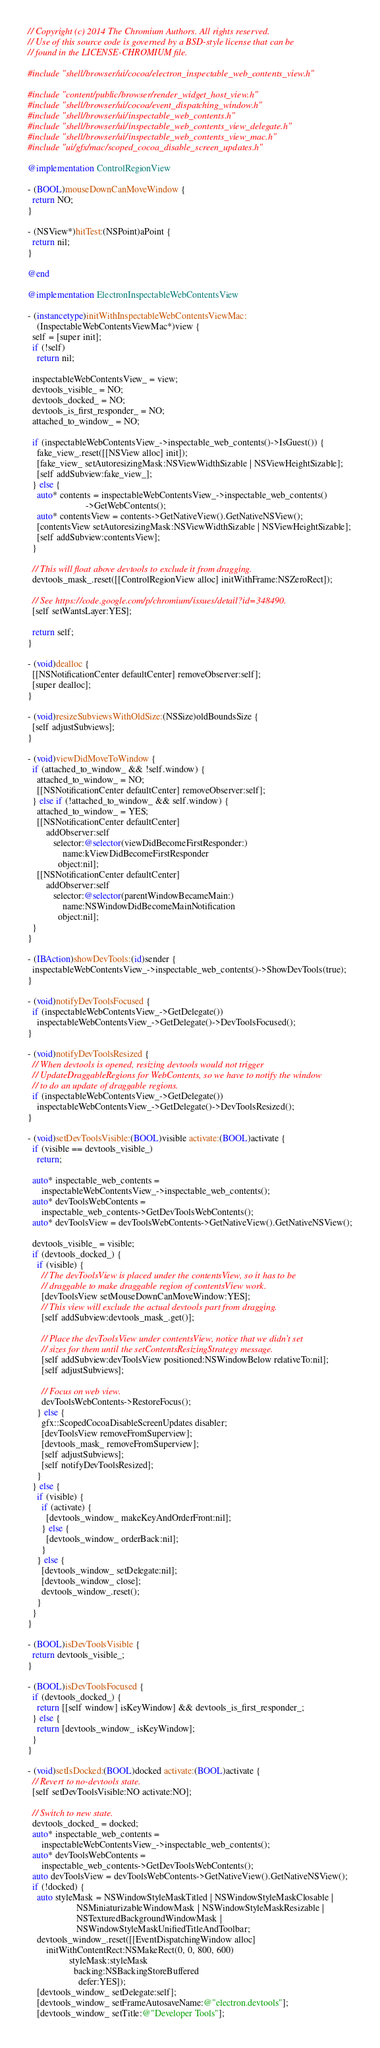<code> <loc_0><loc_0><loc_500><loc_500><_ObjectiveC_>// Copyright (c) 2014 The Chromium Authors. All rights reserved.
// Use of this source code is governed by a BSD-style license that can be
// found in the LICENSE-CHROMIUM file.

#include "shell/browser/ui/cocoa/electron_inspectable_web_contents_view.h"

#include "content/public/browser/render_widget_host_view.h"
#include "shell/browser/ui/cocoa/event_dispatching_window.h"
#include "shell/browser/ui/inspectable_web_contents.h"
#include "shell/browser/ui/inspectable_web_contents_view_delegate.h"
#include "shell/browser/ui/inspectable_web_contents_view_mac.h"
#include "ui/gfx/mac/scoped_cocoa_disable_screen_updates.h"

@implementation ControlRegionView

- (BOOL)mouseDownCanMoveWindow {
  return NO;
}

- (NSView*)hitTest:(NSPoint)aPoint {
  return nil;
}

@end

@implementation ElectronInspectableWebContentsView

- (instancetype)initWithInspectableWebContentsViewMac:
    (InspectableWebContentsViewMac*)view {
  self = [super init];
  if (!self)
    return nil;

  inspectableWebContentsView_ = view;
  devtools_visible_ = NO;
  devtools_docked_ = NO;
  devtools_is_first_responder_ = NO;
  attached_to_window_ = NO;

  if (inspectableWebContentsView_->inspectable_web_contents()->IsGuest()) {
    fake_view_.reset([[NSView alloc] init]);
    [fake_view_ setAutoresizingMask:NSViewWidthSizable | NSViewHeightSizable];
    [self addSubview:fake_view_];
  } else {
    auto* contents = inspectableWebContentsView_->inspectable_web_contents()
                         ->GetWebContents();
    auto* contentsView = contents->GetNativeView().GetNativeNSView();
    [contentsView setAutoresizingMask:NSViewWidthSizable | NSViewHeightSizable];
    [self addSubview:contentsView];
  }

  // This will float above devtools to exclude it from dragging.
  devtools_mask_.reset([[ControlRegionView alloc] initWithFrame:NSZeroRect]);

  // See https://code.google.com/p/chromium/issues/detail?id=348490.
  [self setWantsLayer:YES];

  return self;
}

- (void)dealloc {
  [[NSNotificationCenter defaultCenter] removeObserver:self];
  [super dealloc];
}

- (void)resizeSubviewsWithOldSize:(NSSize)oldBoundsSize {
  [self adjustSubviews];
}

- (void)viewDidMoveToWindow {
  if (attached_to_window_ && !self.window) {
    attached_to_window_ = NO;
    [[NSNotificationCenter defaultCenter] removeObserver:self];
  } else if (!attached_to_window_ && self.window) {
    attached_to_window_ = YES;
    [[NSNotificationCenter defaultCenter]
        addObserver:self
           selector:@selector(viewDidBecomeFirstResponder:)
               name:kViewDidBecomeFirstResponder
             object:nil];
    [[NSNotificationCenter defaultCenter]
        addObserver:self
           selector:@selector(parentWindowBecameMain:)
               name:NSWindowDidBecomeMainNotification
             object:nil];
  }
}

- (IBAction)showDevTools:(id)sender {
  inspectableWebContentsView_->inspectable_web_contents()->ShowDevTools(true);
}

- (void)notifyDevToolsFocused {
  if (inspectableWebContentsView_->GetDelegate())
    inspectableWebContentsView_->GetDelegate()->DevToolsFocused();
}

- (void)notifyDevToolsResized {
  // When devtools is opened, resizing devtools would not trigger
  // UpdateDraggableRegions for WebContents, so we have to notify the window
  // to do an update of draggable regions.
  if (inspectableWebContentsView_->GetDelegate())
    inspectableWebContentsView_->GetDelegate()->DevToolsResized();
}

- (void)setDevToolsVisible:(BOOL)visible activate:(BOOL)activate {
  if (visible == devtools_visible_)
    return;

  auto* inspectable_web_contents =
      inspectableWebContentsView_->inspectable_web_contents();
  auto* devToolsWebContents =
      inspectable_web_contents->GetDevToolsWebContents();
  auto* devToolsView = devToolsWebContents->GetNativeView().GetNativeNSView();

  devtools_visible_ = visible;
  if (devtools_docked_) {
    if (visible) {
      // The devToolsView is placed under the contentsView, so it has to be
      // draggable to make draggable region of contentsView work.
      [devToolsView setMouseDownCanMoveWindow:YES];
      // This view will exclude the actual devtools part from dragging.
      [self addSubview:devtools_mask_.get()];

      // Place the devToolsView under contentsView, notice that we didn't set
      // sizes for them until the setContentsResizingStrategy message.
      [self addSubview:devToolsView positioned:NSWindowBelow relativeTo:nil];
      [self adjustSubviews];

      // Focus on web view.
      devToolsWebContents->RestoreFocus();
    } else {
      gfx::ScopedCocoaDisableScreenUpdates disabler;
      [devToolsView removeFromSuperview];
      [devtools_mask_ removeFromSuperview];
      [self adjustSubviews];
      [self notifyDevToolsResized];
    }
  } else {
    if (visible) {
      if (activate) {
        [devtools_window_ makeKeyAndOrderFront:nil];
      } else {
        [devtools_window_ orderBack:nil];
      }
    } else {
      [devtools_window_ setDelegate:nil];
      [devtools_window_ close];
      devtools_window_.reset();
    }
  }
}

- (BOOL)isDevToolsVisible {
  return devtools_visible_;
}

- (BOOL)isDevToolsFocused {
  if (devtools_docked_) {
    return [[self window] isKeyWindow] && devtools_is_first_responder_;
  } else {
    return [devtools_window_ isKeyWindow];
  }
}

- (void)setIsDocked:(BOOL)docked activate:(BOOL)activate {
  // Revert to no-devtools state.
  [self setDevToolsVisible:NO activate:NO];

  // Switch to new state.
  devtools_docked_ = docked;
  auto* inspectable_web_contents =
      inspectableWebContentsView_->inspectable_web_contents();
  auto* devToolsWebContents =
      inspectable_web_contents->GetDevToolsWebContents();
  auto devToolsView = devToolsWebContents->GetNativeView().GetNativeNSView();
  if (!docked) {
    auto styleMask = NSWindowStyleMaskTitled | NSWindowStyleMaskClosable |
                     NSMiniaturizableWindowMask | NSWindowStyleMaskResizable |
                     NSTexturedBackgroundWindowMask |
                     NSWindowStyleMaskUnifiedTitleAndToolbar;
    devtools_window_.reset([[EventDispatchingWindow alloc]
        initWithContentRect:NSMakeRect(0, 0, 800, 600)
                  styleMask:styleMask
                    backing:NSBackingStoreBuffered
                      defer:YES]);
    [devtools_window_ setDelegate:self];
    [devtools_window_ setFrameAutosaveName:@"electron.devtools"];
    [devtools_window_ setTitle:@"Developer Tools"];</code> 